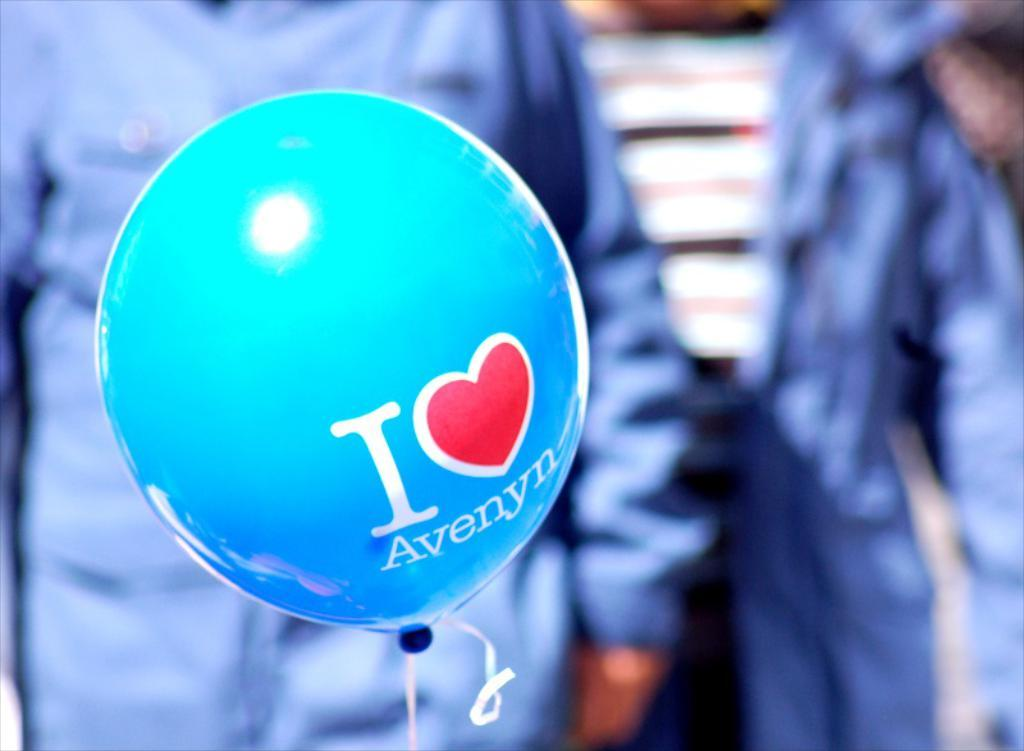What object is present in the image that is typically filled with air? There is a balloon in the image. What is written on the balloon? The balloon has text written on it. How would you describe the background of the image? The background of the image is blurry. Where is the table located in the image? There is no table present in the image. How many frogs can be seen sitting on the egg in the image? There are no frogs or eggs present in the image. 